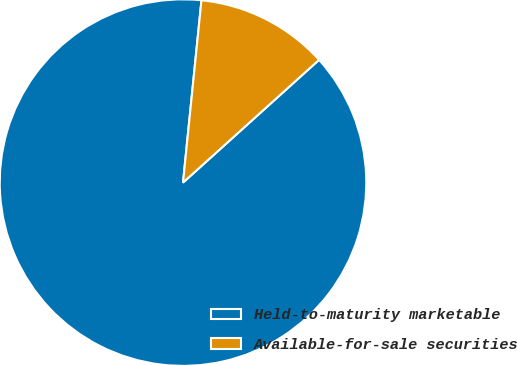Convert chart to OTSL. <chart><loc_0><loc_0><loc_500><loc_500><pie_chart><fcel>Held-to-maturity marketable<fcel>Available-for-sale securities<nl><fcel>88.29%<fcel>11.71%<nl></chart> 